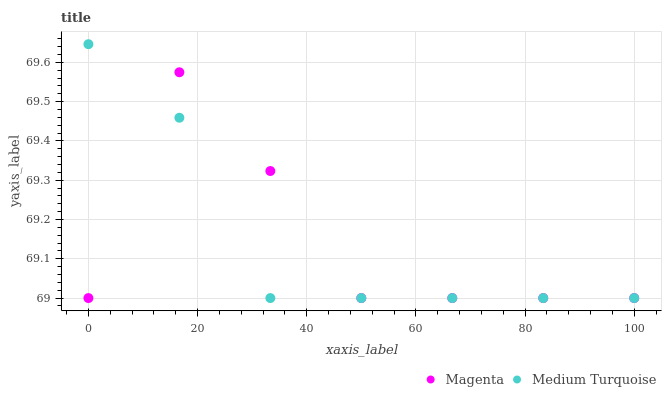Does Medium Turquoise have the minimum area under the curve?
Answer yes or no. Yes. Does Magenta have the maximum area under the curve?
Answer yes or no. Yes. Does Medium Turquoise have the maximum area under the curve?
Answer yes or no. No. Is Medium Turquoise the smoothest?
Answer yes or no. Yes. Is Magenta the roughest?
Answer yes or no. Yes. Is Medium Turquoise the roughest?
Answer yes or no. No. Does Magenta have the lowest value?
Answer yes or no. Yes. Does Medium Turquoise have the highest value?
Answer yes or no. Yes. Does Medium Turquoise intersect Magenta?
Answer yes or no. Yes. Is Medium Turquoise less than Magenta?
Answer yes or no. No. Is Medium Turquoise greater than Magenta?
Answer yes or no. No. 